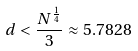<formula> <loc_0><loc_0><loc_500><loc_500>d < \frac { N ^ { \frac { 1 } { 4 } } } { 3 } \approx 5 . 7 8 2 8</formula> 